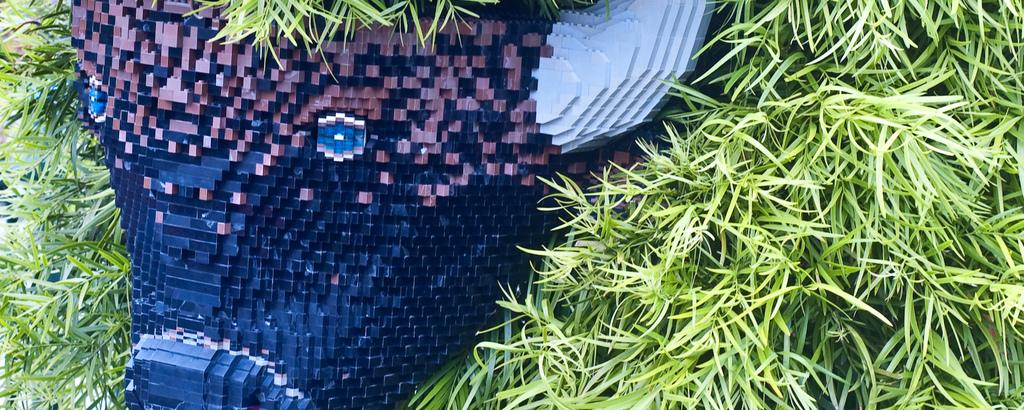What type of vegetation is visible in the front of the image? There is grass in the front of the image. What object with blue and red colors can be seen in the image? The object with blue and red colors is not specified in the facts provided. What other color is present on the object in the image? The object has a gray color in the image. What type of jam is being served for dinner in the image? There is no jam or dinner present in the image. Is the umbrella open or closed in the image? There is no umbrella present in the image. 